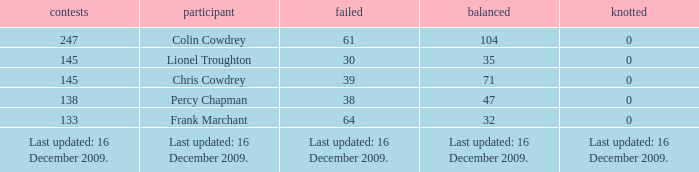Give me the full table as a dictionary. {'header': ['contests', 'participant', 'failed', 'balanced', 'knotted'], 'rows': [['247', 'Colin Cowdrey', '61', '104', '0'], ['145', 'Lionel Troughton', '30', '35', '0'], ['145', 'Chris Cowdrey', '39', '71', '0'], ['138', 'Percy Chapman', '38', '47', '0'], ['133', 'Frank Marchant', '64', '32', '0'], ['Last updated: 16 December 2009.', 'Last updated: 16 December 2009.', 'Last updated: 16 December 2009.', 'Last updated: 16 December 2009.', 'Last updated: 16 December 2009.']]} I want to know the tie for drawn of 47 0.0. 